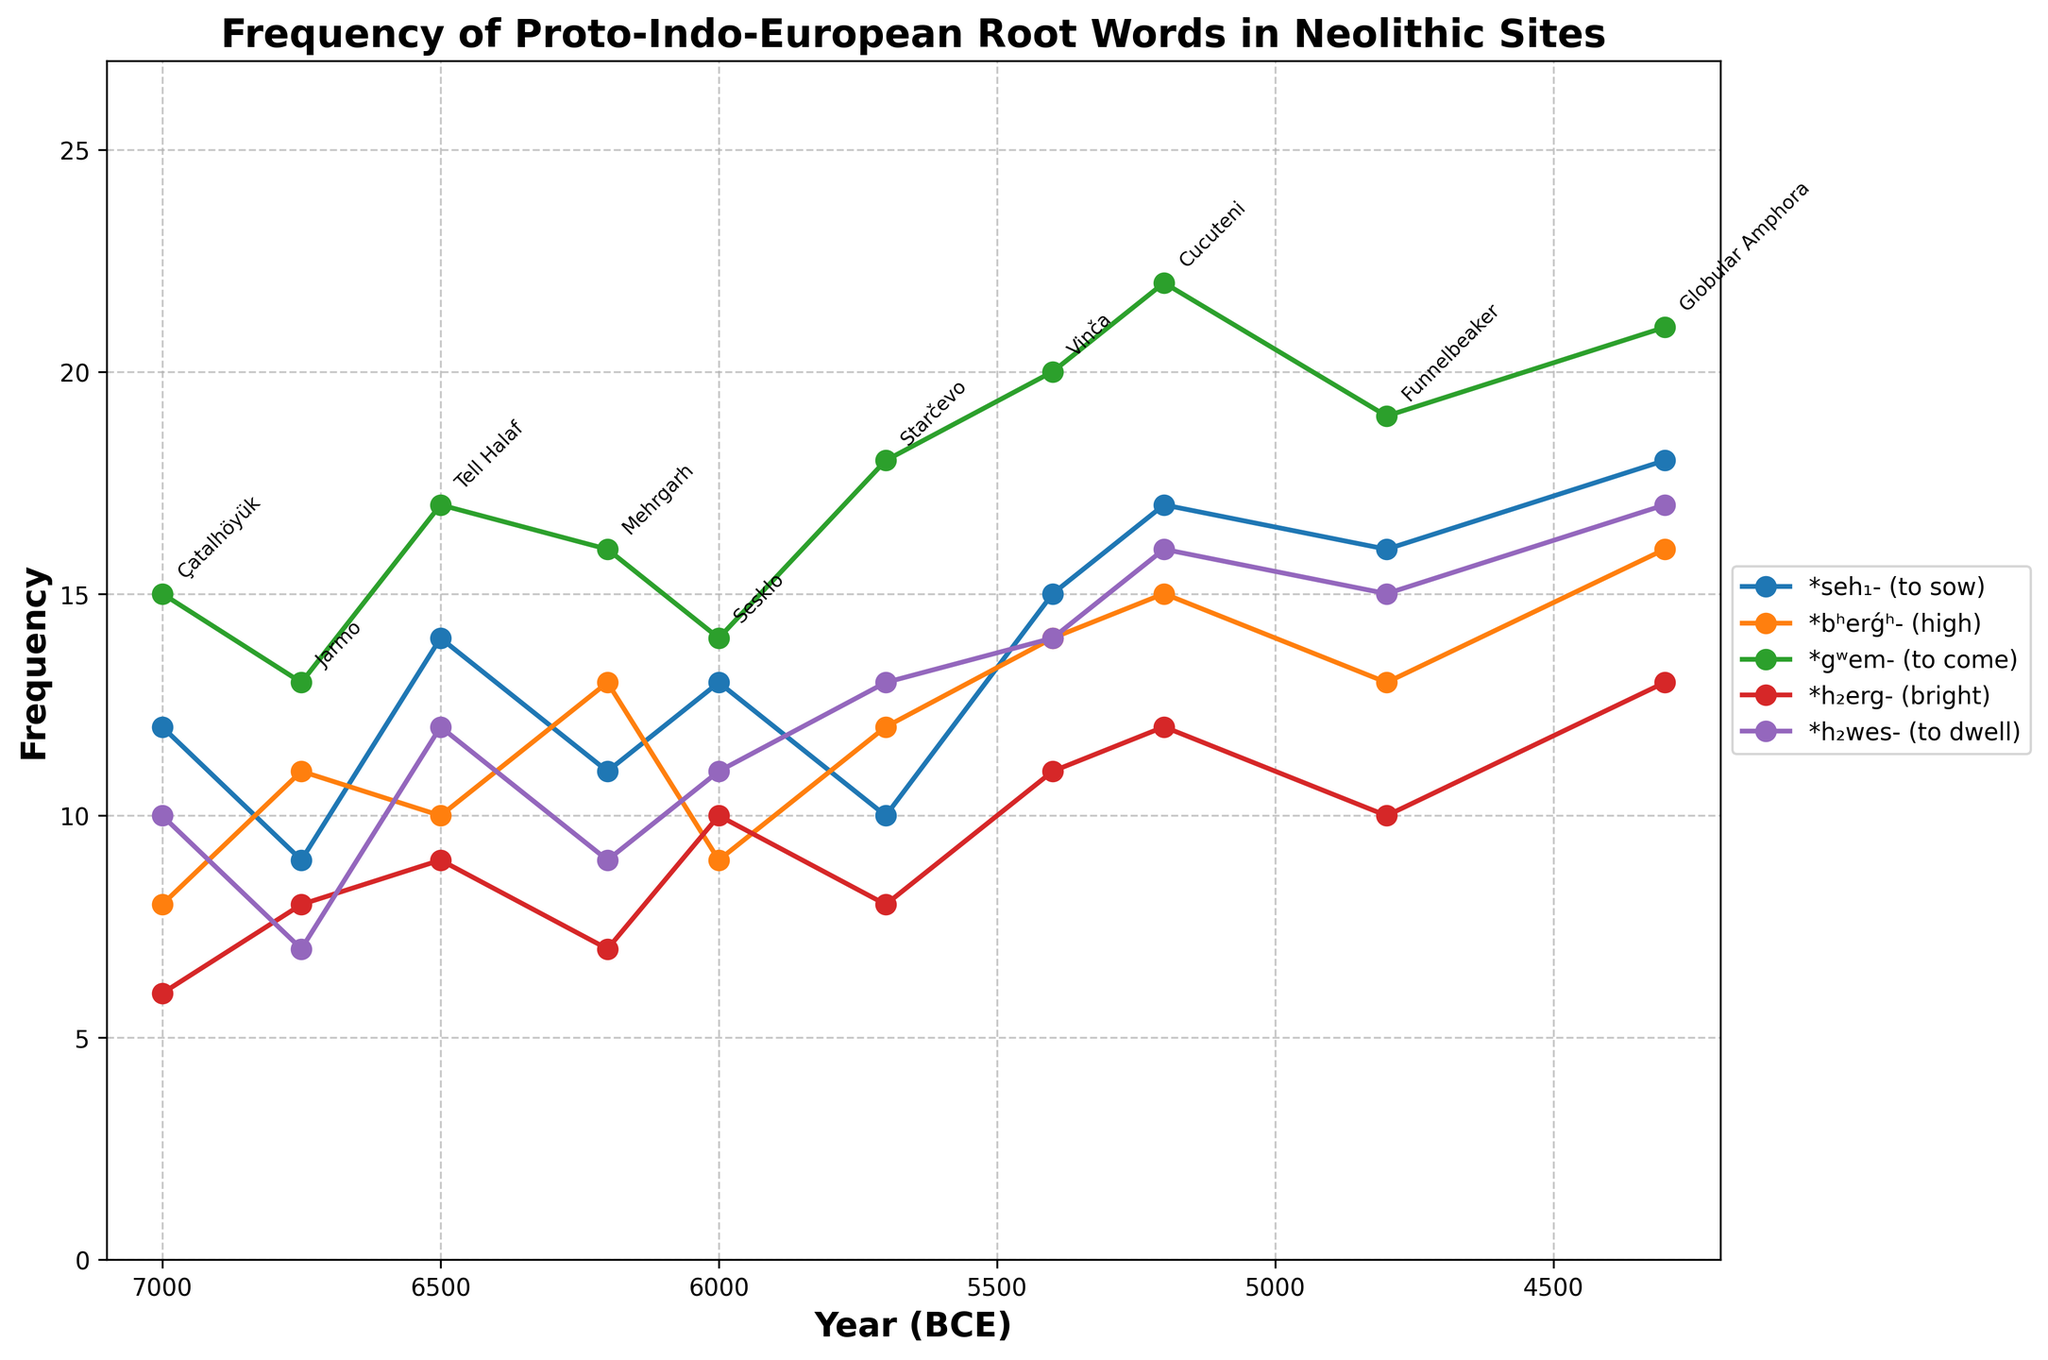Which site showed the highest frequency of *gʷem- (to come)*? Looking at the plot, the highest point in the *gʷem- (to come)* line (often marked with markers such as circles or dots) will indicate the highest frequency. The data shows that Vinča has the highest frequency of *gʷem- (to come)* with a value of 20.
Answer: Vinča What is the combined frequency of *seh₁- (to sow)* and *h₂wes- (to dwell)* at Cucuteni? Identify the data points for *seh₁- (to sow)* and *h₂wes- (to dwell)* at Cucuteni from the plot, which are frequencies of 17 and 16 respectively. Sum these values: 17 + 16 = 33.
Answer: 33 Between 6000 BCE and 4300 BCE, did the frequency of *bʰerǵʰ- (high)* generally increase, decrease, or remain constant across the sites? Track the *bʰerǵʰ- (high)* line on the plot from 6000 BCE (Sesklo) to 4300 BCE (Globular Amphora). Observe that the line generally increases, moving from 9 at Sesklo to 16 at Globular Amphora.
Answer: Increase Between which two consecutive sites is the frequency increase of *h₂erg- (bright)* the largest? Looking at the line specifically representing *h₂erg- (bright)*, find the pair of consecutive sites with the greatest vertical difference. The largest increase is between Funnelbeaker (10) and Globular Amphora (13), which is 3.
Answer: Funnelbeaker to Globular Amphora What is the trend of *seh₁- (to sow)* from 7000 BCE to 4300 BCE? By examining the line representing *seh₁- (to sow)* from left to right across the years, identify the trend. The graph shows a general increase in frequency from 12 at Çatalhöyük to 18 at Globular Amphora.
Answer: Increasing trend Which root word has the least variation in frequency across the sites? To determine this, visually compare the range (difference between maximum and minimum values) for each root word's line on the plot. *h₂erg- (bright)* shows the least variation with frequencies ranging between 6 and 13, a variation of 7.
Answer: *h₂erg- (bright)* What is the average frequency of *bʰerǵʰ- (high)* across all the sites? From the graph, sum the frequencies of *bʰerǵʰ- (high)* (8 + 11 + 10 + 13 + 9 + 12 + 14 + 15 + 13 + 16 = 121) and divide by the number of sites (10). Average = 121 / 10 = 12.1.
Answer: 12.1 In which year does *h₂wes- (to dwell)* reach its maximum frequency, and what is the frequency? Assess the highest peak in the *h₂wes- (to dwell)* line. It reaches its maximum frequency of 17 at Globular Amphora in 4300 BCE.
Answer: 4300 BCE, 17 